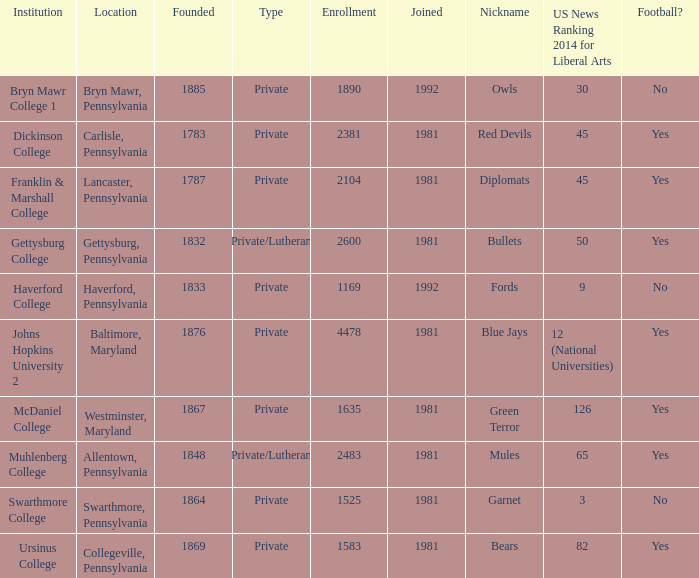What category of school is located in swarthmore, pennsylvania? Private. 